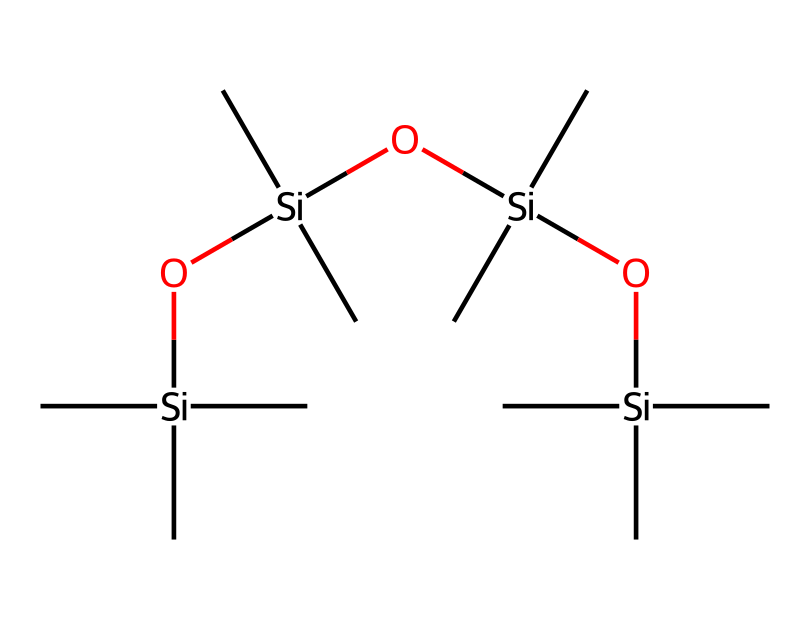how many silicon atoms are in this structure? The SMILES representation indicates there are four silicon atoms, as each '[Si]' corresponds to a silicon atom in the chain.
Answer: four what type of lubricant is represented by this structure? The presence of silicon is characteristic of silicone-based lubricants, commonly used for their properties such as being non-toxic and moisture-resistant.
Answer: silicone-based how many oxygen atoms are present in this structure? Each '[O]' represents an oxygen atom, and there are three '[O]' in the SMILES notation. Therefore, there are three oxygen atoms.
Answer: three what is one property of silicone-based lubricants? Silicone-based lubricants are known for their ability to reduce friction, which is beneficial in applications like guitar strings where smooth sliding is needed.
Answer: reduce friction what does the presence of multiple carbon groups indicate about this lubricant? The multiple carbon groups (represented by '(C)' in the SMILES) indicate that it has a hydrophobic character, enhancing lubricant performance by repelling water and preventing corrosion.
Answer: hydrophobic character which part of the chemical structure contributes to its lubrication properties? The silicone backbone, specifically the silicon-oxygen chains, is crucial for lubrication properties due to their flexibility and ability to form a slippery surface.
Answer: silicone backbone 